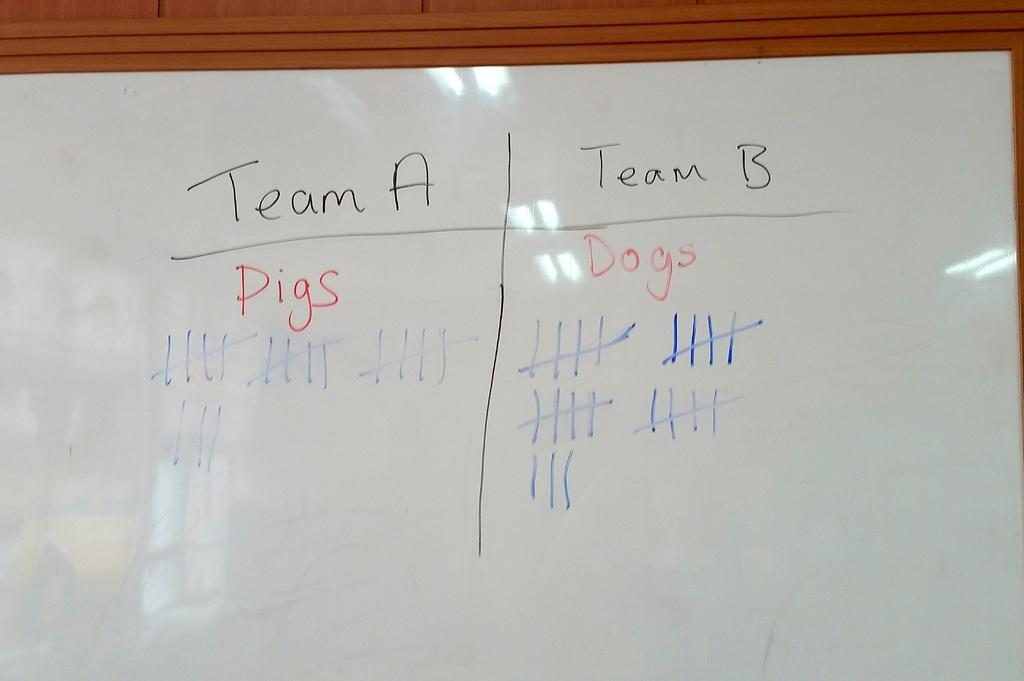Provide a one-sentence caption for the provided image. A white board has a column for Team A and Team B with score tallies. 